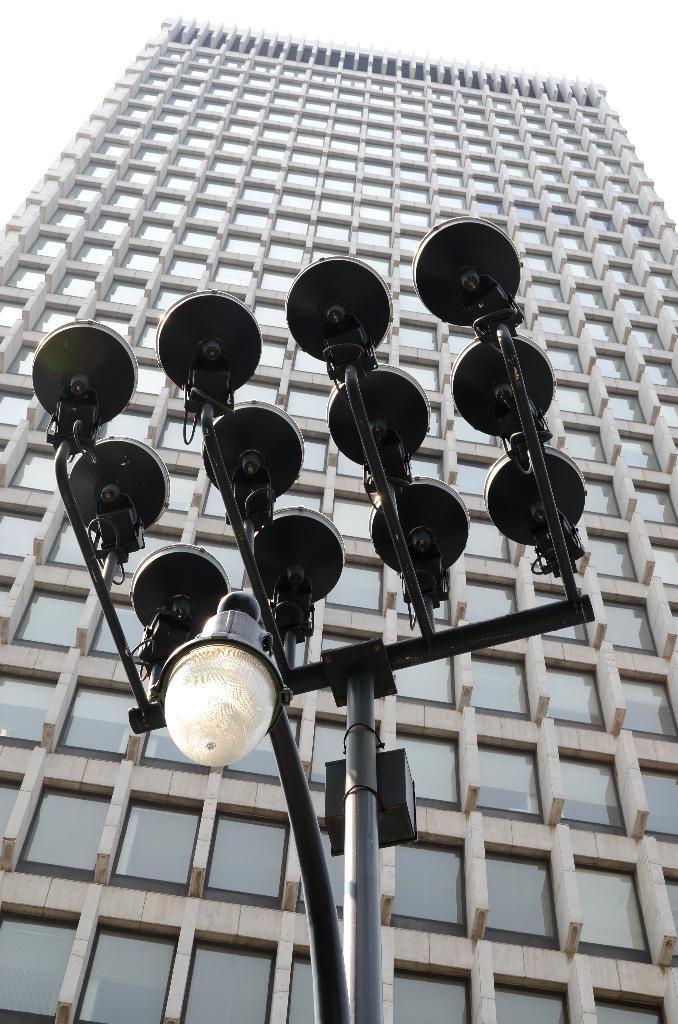In one or two sentences, can you explain what this image depicts? In this picture I can see a building and a pole light and a cloudy sky. 